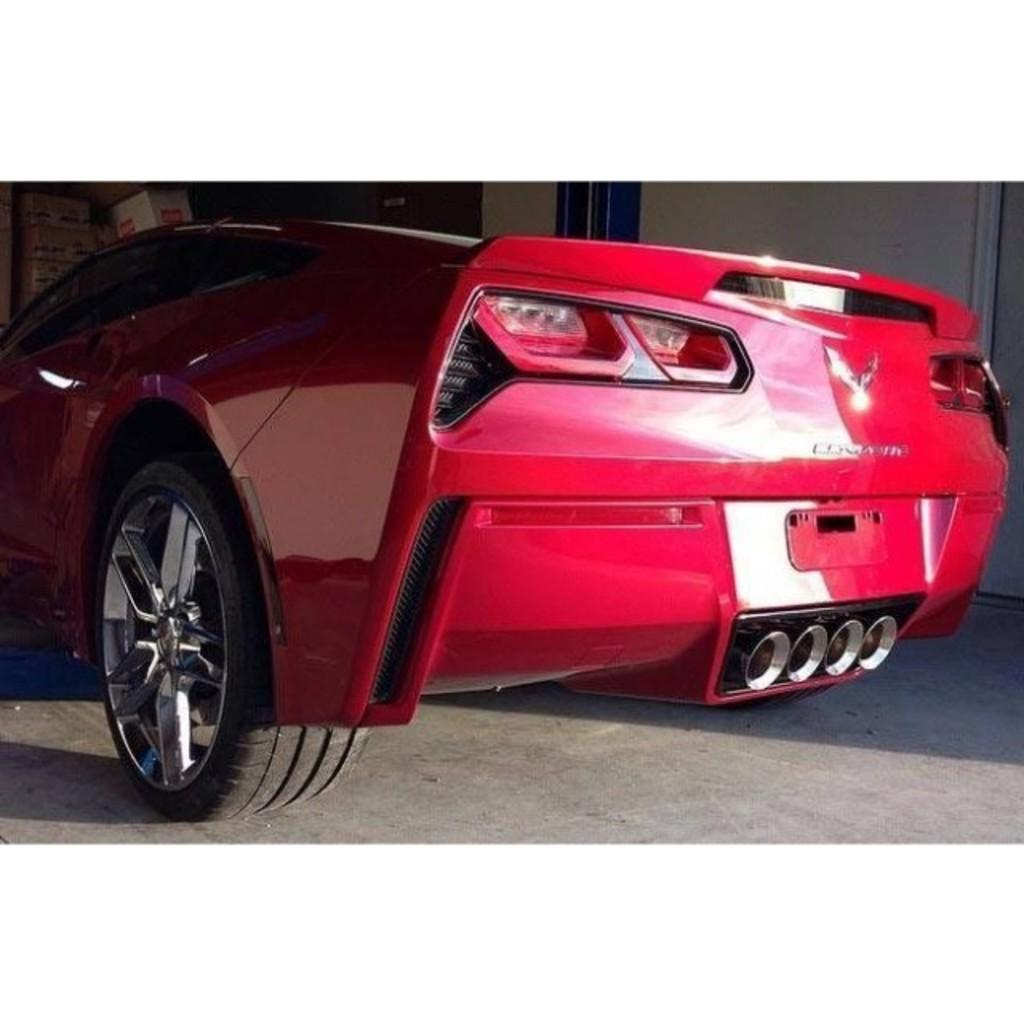What is placed on the floor in the image? There is a car on the floor in the image. What can be seen in the background of the image? There are carton boxes, a wall, and other objects in the background of the image. What type of ship can be seen sailing in the background of the image? There is no ship present in the image; it only features a car on the floor and objects in the background. 